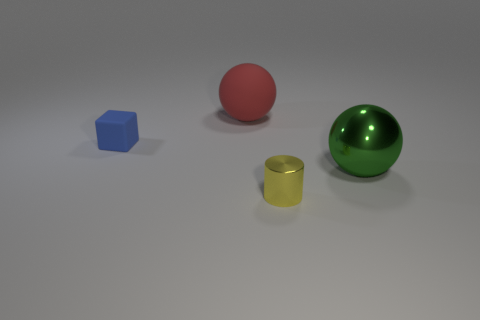Are there any cylinders in front of the tiny thing that is in front of the tiny thing that is behind the yellow cylinder?
Provide a succinct answer. No. What is the color of the shiny ball?
Offer a terse response. Green. There is a green metal ball; are there any shiny cylinders in front of it?
Make the answer very short. Yes. Do the large metallic object and the small object that is in front of the small blue rubber thing have the same shape?
Make the answer very short. No. What number of other things are there of the same material as the blue object
Provide a short and direct response. 1. What is the color of the large object right of the big object that is left of the shiny ball to the right of the tiny matte object?
Provide a short and direct response. Green. What shape is the small thing that is to the right of the big object to the left of the small shiny thing?
Make the answer very short. Cylinder. Is the number of yellow metal objects behind the cylinder greater than the number of small gray shiny balls?
Ensure brevity in your answer.  No. There is a small object to the right of the red rubber ball; is it the same shape as the red matte thing?
Your answer should be compact. No. Are there any green things of the same shape as the large red matte thing?
Your answer should be compact. Yes. 